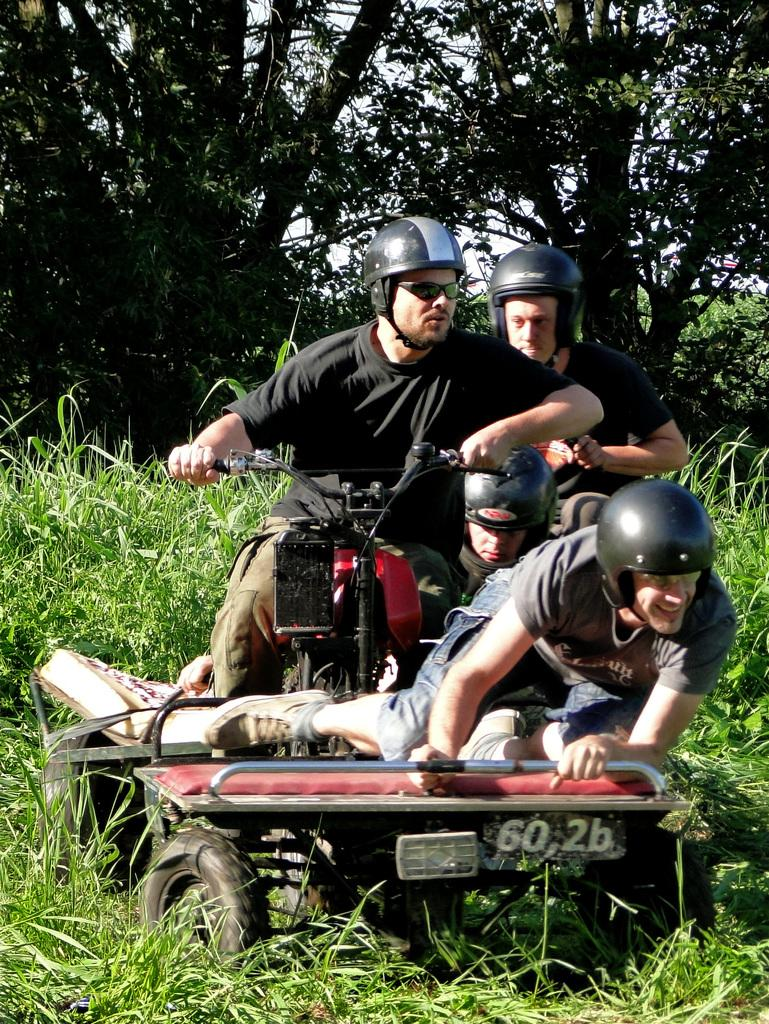How many people are in the image? There are four people in the image. What are the people wearing on their heads? The people are wearing helmets. What are the people sitting on in the image? The people are sitting on a vehicle. What type of natural environment can be seen in the image? There is grass and trees visible in the image. What is visible at the top of the image? The sky is visible at the top of the image. What color of paint is being used to cover the patch on the tray in the image? There is no patch or tray present in the image; it features four people wearing helmets and sitting on a vehicle in a natural environment with grass, trees, and a visible sky. 